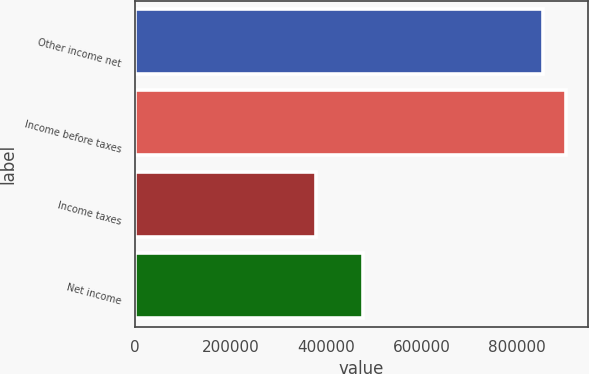<chart> <loc_0><loc_0><loc_500><loc_500><bar_chart><fcel>Other income net<fcel>Income before taxes<fcel>Income taxes<fcel>Net income<nl><fcel>855564<fcel>903327<fcel>377958<fcel>477626<nl></chart> 